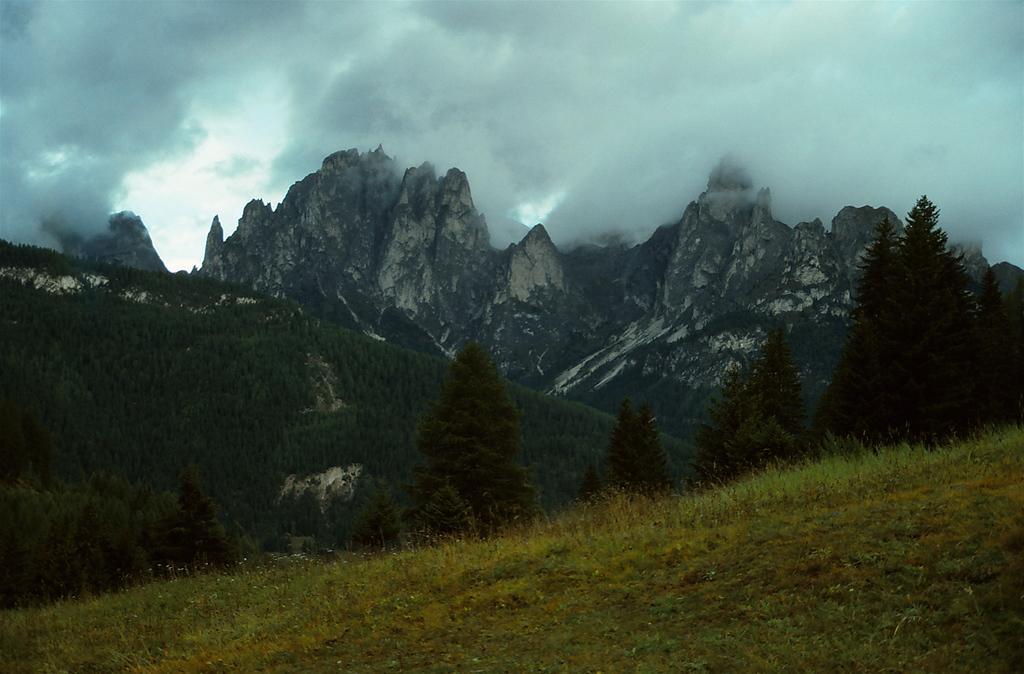Please provide a concise description of this image. In this image we can see some grass, trees and in the background of the image there are some mountains and cloudy sky. 